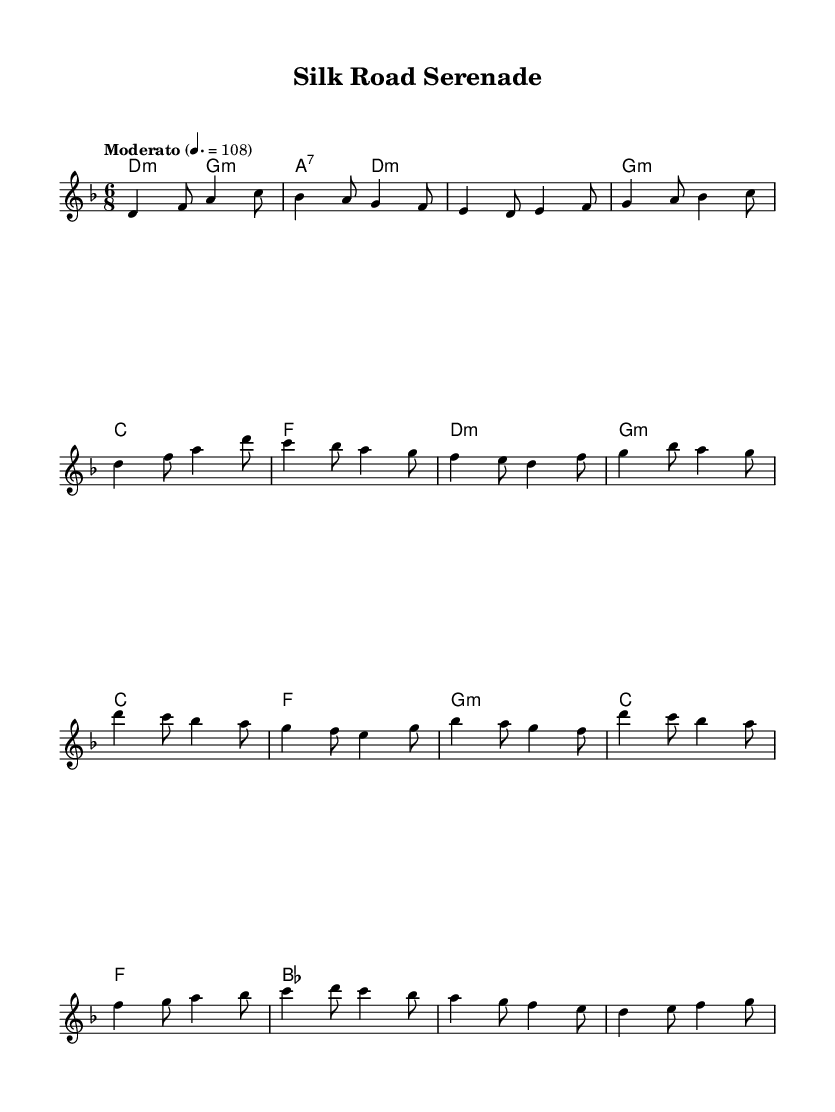What is the key signature of this music? The key signature is D minor, which has one flat (B flat). This is indicated at the beginning of the sheet music where the key signature is shown.
Answer: D minor What is the time signature of this music? The time signature is 6/8, which is shown at the beginning of the sheet music. This means there are six eighth notes in each measure.
Answer: 6/8 What is the tempo marking of the piece? The tempo marking indicates "Moderato," which guides the performer to play at a moderate speed. This is shown in the tempo indication in the score.
Answer: Moderato How many measures are in the provided melody? By counting the measures in the melody section of the sheet music, we see there are a total of sixteen measures. Each group separated by vertical lines indicates the end of a measure.
Answer: Sixteen What type of chord is featured in the first measure? The first measure features a D minor chord, as indicated by the chord symbol placed above the melody line in the sheet music.
Answer: D minor What is the structure of the piece? The structure includes an Intro, Verse 1 (partial), Chorus (partial), and Bridge (partial), as denoted by their labels in the sheet music, providing a clear outline of the musical sections.
Answer: Intro, Verse 1, Chorus, Bridge 